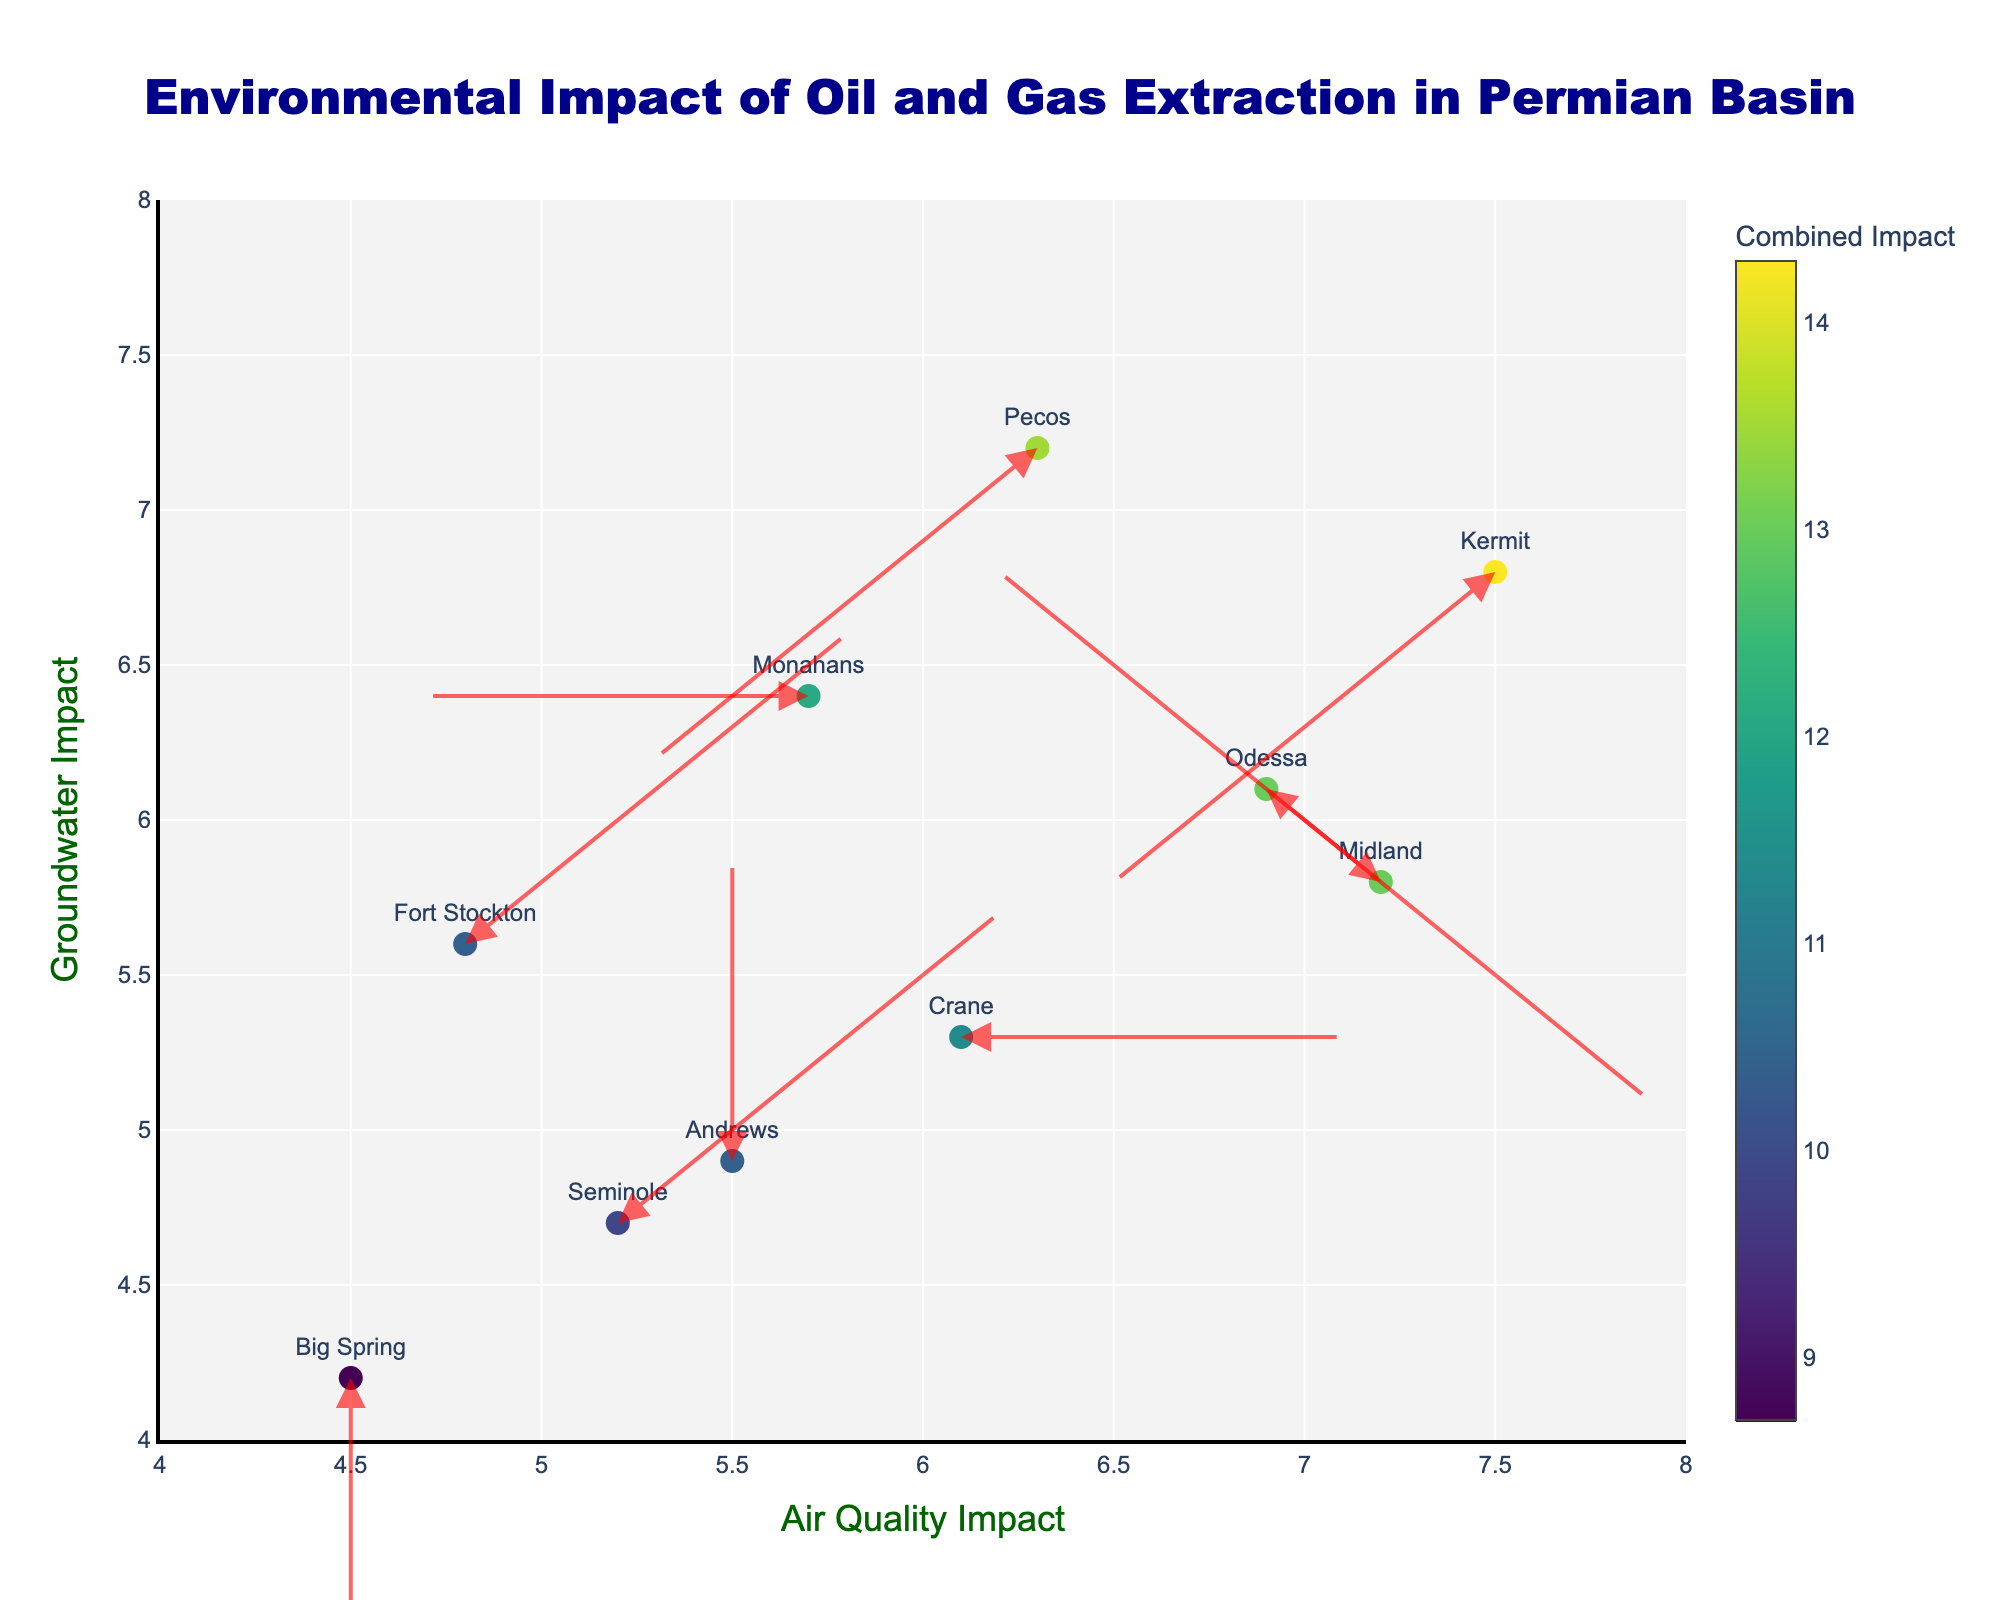How many locations are depicted in the plot? By visual counting of the scatter plot's data points and associated labels, we observe there are 10 locations labeled in the figure.
Answer: 10 What is the title of the figure? The title is prominently displayed at the top center of the plot. Reading it directly from the plot provides the answer.
Answer: Environmental Impact of Oil and Gas Extraction in Permian Basin Which location has the highest combined impact on air quality and groundwater? Summing the air quality impact and groundwater impact values for each location, Kermit has the highest combined impact (7.5 + 6.8 = 14.3).
Answer: Kermit What are the x-axis and y-axis titles? The titles of the axes are positioned along the respective axes. The x-axis title reads 'Air Quality Impact' and the y-axis title reads 'Groundwater Impact'.
Answer: Air Quality Impact, Groundwater Impact Which location shows an arrow pointing towards the negative x-direction and positive y-direction? By observing the direction of the arrows, it is seen that Midland has an arrow pointing towards the negative x-direction and positive y-direction.
Answer: Midland What is the color pattern used for the markers in the scatter plot? The markers are colored using a Viridis colorscale, which ranges from dark blue to yellow, based on the combined impact of air quality and groundwater.
Answer: Viridis colorscale What is the range of the x-axis? The x-axis range can be determined by looking at the axis boundaries, which are set from 4 to 8.
Answer: 4 to 8 Which location indicates the greatest increase in groundwater impact but a decrease in air quality impact (arrow pointing towards negative x and positive y)? By observing the direction of the arrows and the values, Pecos is the location showing this pattern.
Answer: Pecos In which region does the scatter plot appear most densely populated? Visually inspecting the density of the data points, they cluster densely around the central region between values 5.5 to 6 for air quality and 5 to 6.5 for groundwater.
Answer: Central region around 5.5 - 6 air quality and 5 - 6.5 groundwater What is the direction of the arrow for the location with the lowest air quality impact? Big Spring, with an air quality impact of 4.5, has its arrow pointing downward (negative y-direction).
Answer: Downward (negative y-direction) 